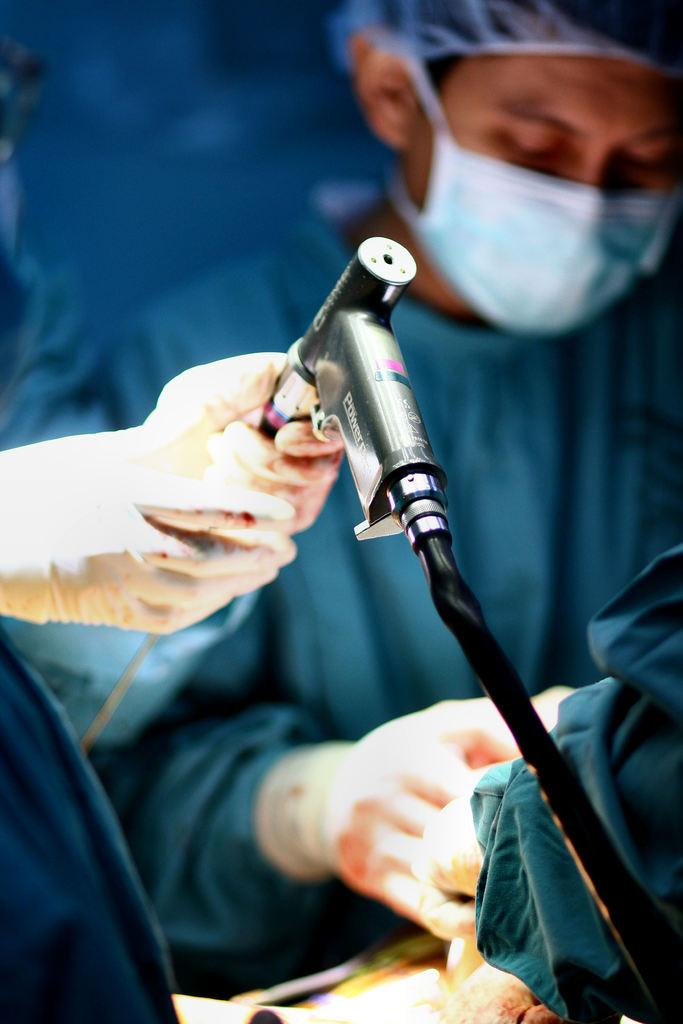How many people are in the image? There are people in the image, but the exact number is not specified. What is the person on the left side of the image doing? A person's hands are holding an object on the left side of the image. What type of unit is being used to measure the taste of the object in the image? There is no mention of measuring taste or any units in the image, so this question cannot be answered definitively. 